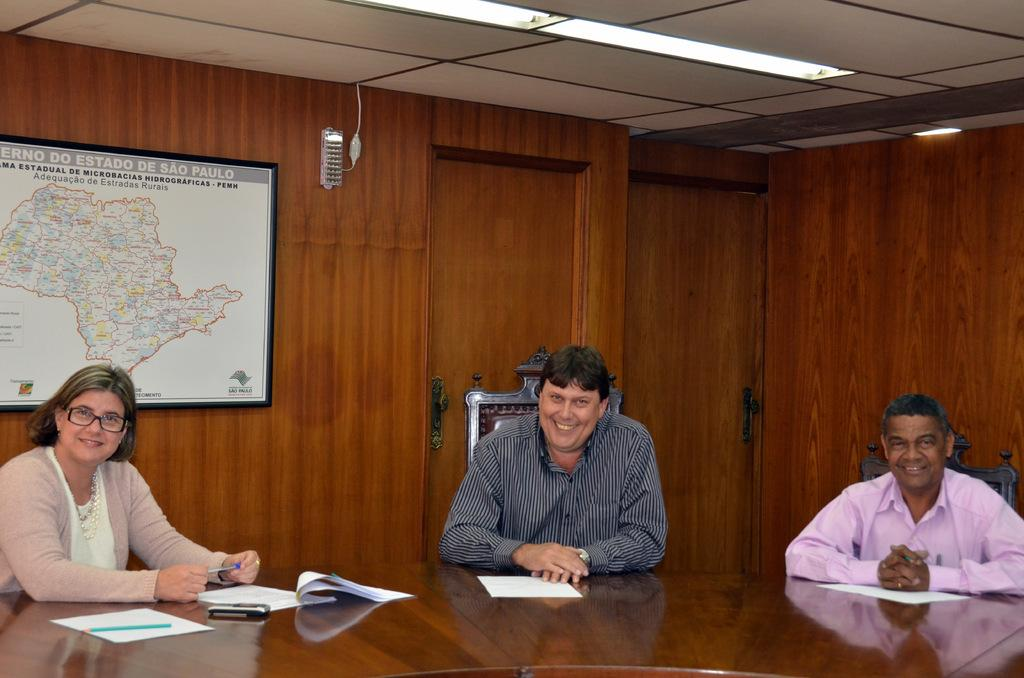How many people are sitting in the image? There are 3 people sitting in the image. What is on the table in the image? There are papers on a table in the image. What is a person holding in the image? A person is holding a pen in the image. What can be seen in the image that might be used for navigation or planning? There is a map in the image. How many doors are visible at the back of the room in the image? There are 2 doors at the back in the image. What type of lighting is present in the image? There are lights on the top in the image. What type of reward is being given to the person holding the paint in the image? There is no person holding paint in the image, and therefore no reward is being given. 